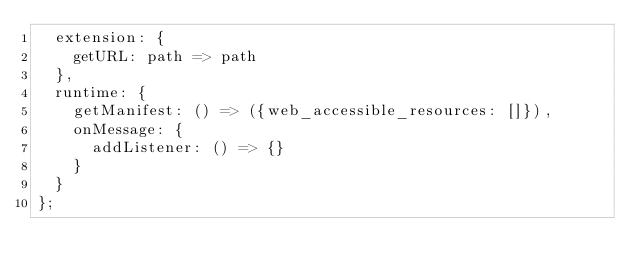Convert code to text. <code><loc_0><loc_0><loc_500><loc_500><_JavaScript_>  extension: {
    getURL: path => path
  },
  runtime: {
    getManifest: () => ({web_accessible_resources: []}),
    onMessage: {
      addListener: () => {}
    }
  }
};
</code> 